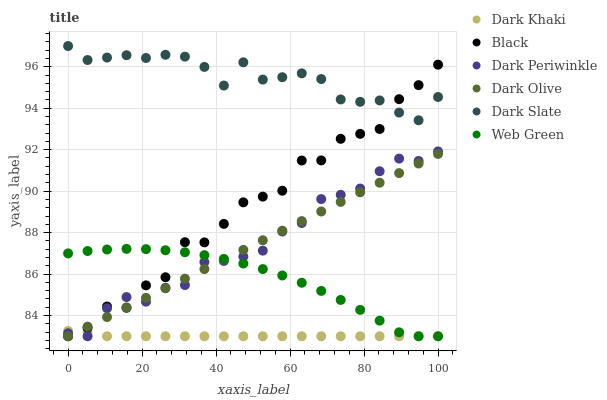Does Dark Khaki have the minimum area under the curve?
Answer yes or no. Yes. Does Dark Slate have the maximum area under the curve?
Answer yes or no. Yes. Does Web Green have the minimum area under the curve?
Answer yes or no. No. Does Web Green have the maximum area under the curve?
Answer yes or no. No. Is Dark Olive the smoothest?
Answer yes or no. Yes. Is Black the roughest?
Answer yes or no. Yes. Is Web Green the smoothest?
Answer yes or no. No. Is Web Green the roughest?
Answer yes or no. No. Does Dark Olive have the lowest value?
Answer yes or no. Yes. Does Dark Slate have the lowest value?
Answer yes or no. No. Does Dark Slate have the highest value?
Answer yes or no. Yes. Does Web Green have the highest value?
Answer yes or no. No. Is Dark Khaki less than Dark Slate?
Answer yes or no. Yes. Is Dark Slate greater than Dark Periwinkle?
Answer yes or no. Yes. Does Dark Periwinkle intersect Black?
Answer yes or no. Yes. Is Dark Periwinkle less than Black?
Answer yes or no. No. Is Dark Periwinkle greater than Black?
Answer yes or no. No. Does Dark Khaki intersect Dark Slate?
Answer yes or no. No. 